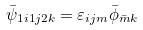<formula> <loc_0><loc_0><loc_500><loc_500>\bar { \psi } _ { 1 i 1 j 2 k } = \varepsilon _ { i j m } \bar { \phi } _ { \bar { m } k }</formula> 